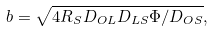Convert formula to latex. <formula><loc_0><loc_0><loc_500><loc_500>b = \sqrt { 4 R _ { S } D _ { O L } D _ { L S } \Phi / D _ { O S } } ,</formula> 